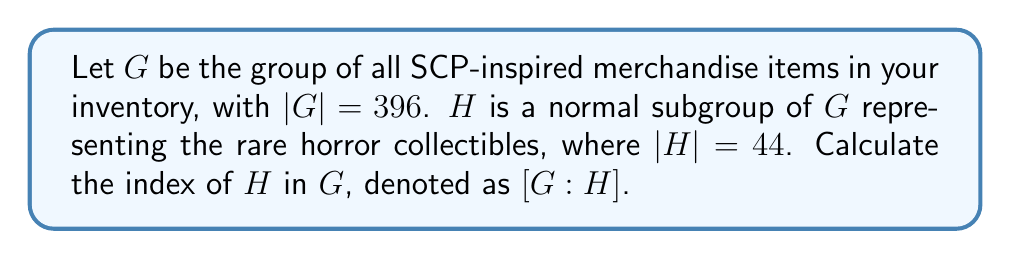Could you help me with this problem? To solve this problem, we need to understand the concept of index in group theory and how it relates to the order of groups.

1. The index of a subgroup H in a group G, denoted as [G:H], is defined as the number of distinct left (or right) cosets of H in G.

2. For finite groups, there's a fundamental theorem that relates the order of the group, the order of the subgroup, and the index:

   $$|G| = |H| \cdot [G:H]$$

3. In this case, we're given:
   - |G| = 396 (total number of SCP-inspired merchandise items)
   - |H| = 44 (number of rare horror collectibles)

4. We can rearrange the equation to solve for [G:H]:

   $$[G:H] = \frac{|G|}{|H|}$$

5. Substituting the values:

   $$[G:H] = \frac{396}{44}$$

6. Simplifying:
   
   $$[G:H] = 9$$

This means there are 9 distinct cosets of H in G, or in other words, the rare horror collectibles subgroup divides the total SCP-inspired merchandise inventory into 9 equal parts.
Answer: $[G:H] = 9$ 